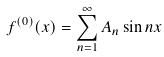<formula> <loc_0><loc_0><loc_500><loc_500>f ^ { ( 0 ) } ( x ) = \sum _ { n = 1 } ^ { \infty } A _ { n } \sin n x</formula> 